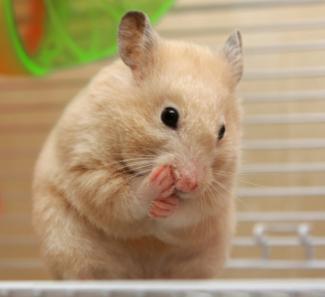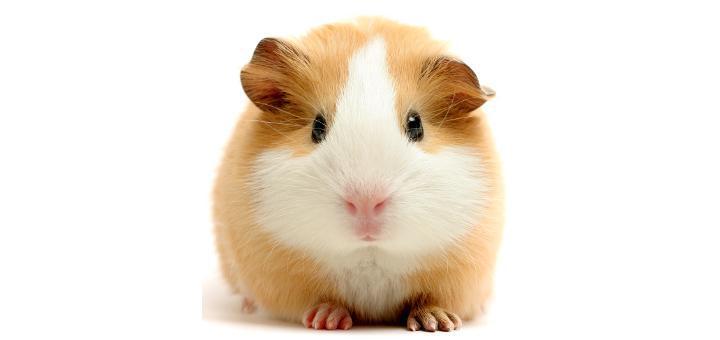The first image is the image on the left, the second image is the image on the right. Given the left and right images, does the statement "A hamster is eating a piece of food." hold true? Answer yes or no. No. 